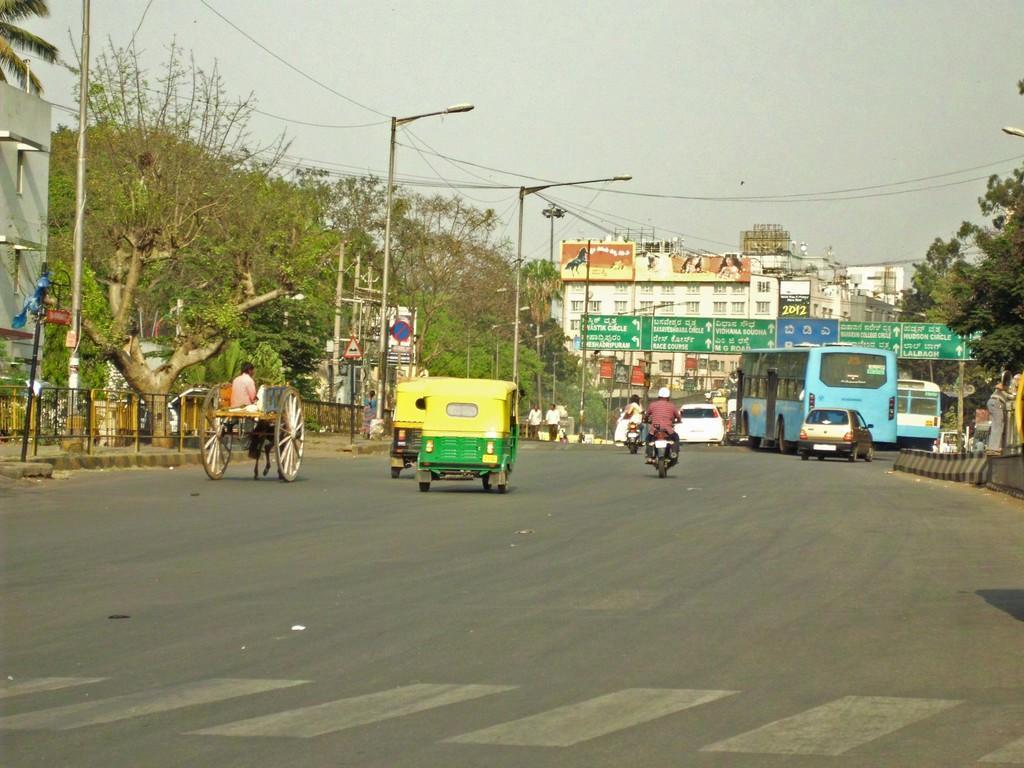In one or two sentences, can you explain what this image depicts? In this image, we can see vehicles and people on the road and in the background, there are trees, buildings, lights, poles, dividers, railings, name boards and sign boards and wires. 